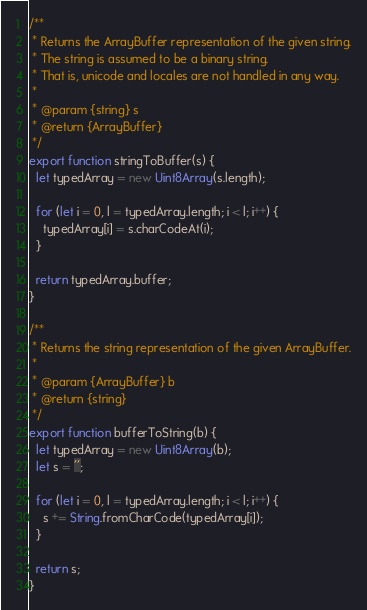Convert code to text. <code><loc_0><loc_0><loc_500><loc_500><_JavaScript_>/**
 * Returns the ArrayBuffer representation of the given string.
 * The string is assumed to be a binary string.
 * That is, unicode and locales are not handled in any way.
 *
 * @param {string} s
 * @return {ArrayBuffer}
 */
export function stringToBuffer(s) {
  let typedArray = new Uint8Array(s.length);

  for (let i = 0, l = typedArray.length; i < l; i++) {
    typedArray[i] = s.charCodeAt(i);
  }

  return typedArray.buffer;
}

/**
 * Returns the string representation of the given ArrayBuffer.
 *
 * @param {ArrayBuffer} b
 * @return {string}
 */
export function bufferToString(b) {
  let typedArray = new Uint8Array(b);
  let s = '';

  for (let i = 0, l = typedArray.length; i < l; i++) {
    s += String.fromCharCode(typedArray[i]);
  }

  return s;
}
</code> 